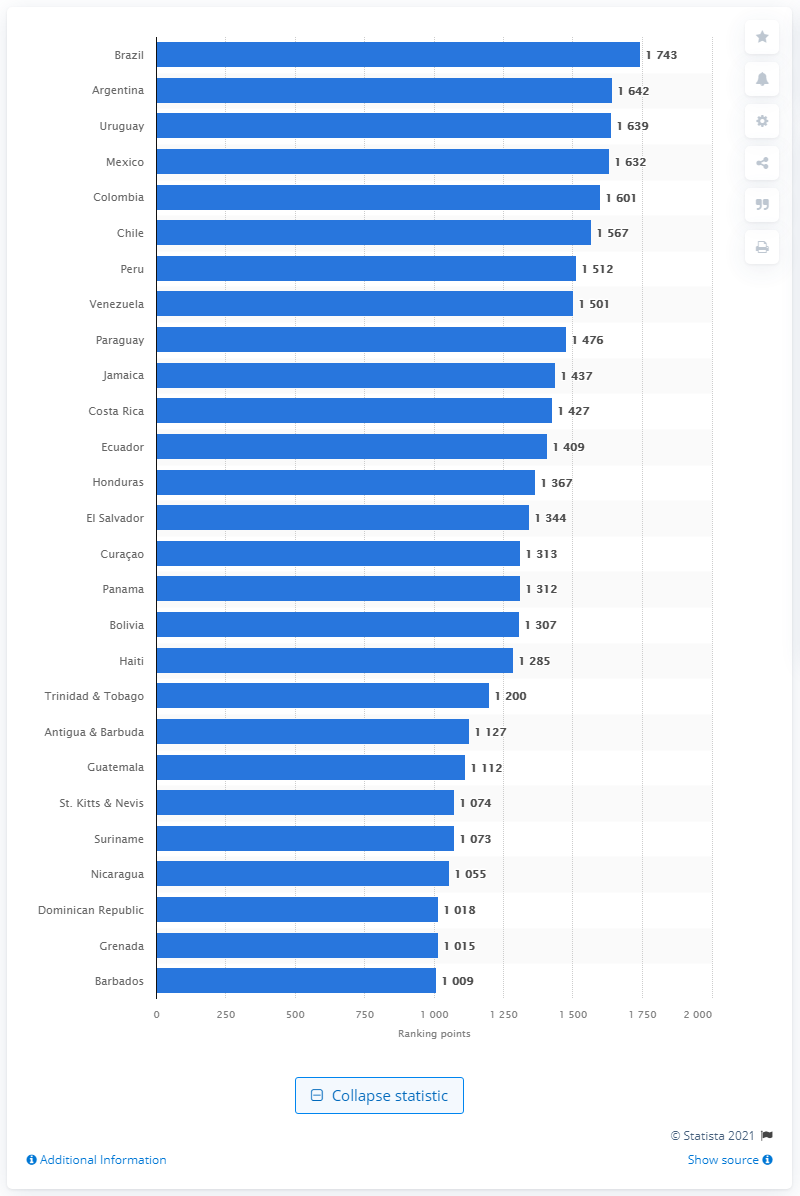Give some essential details in this illustration. According to the FIFA ranking of men's national soccer teams published in February 2021, Brazil leads in Latin America and the Caribbean. 